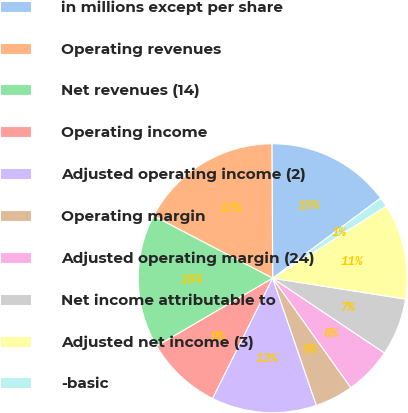Convert chart. <chart><loc_0><loc_0><loc_500><loc_500><pie_chart><fcel>in millions except per share<fcel>Operating revenues<fcel>Net revenues (14)<fcel>Operating income<fcel>Adjusted operating income (2)<fcel>Operating margin<fcel>Adjusted operating margin (24)<fcel>Net income attributable to<fcel>Adjusted net income (3)<fcel>-basic<nl><fcel>14.94%<fcel>17.24%<fcel>16.09%<fcel>9.2%<fcel>12.64%<fcel>4.6%<fcel>5.75%<fcel>6.9%<fcel>11.49%<fcel>1.15%<nl></chart> 